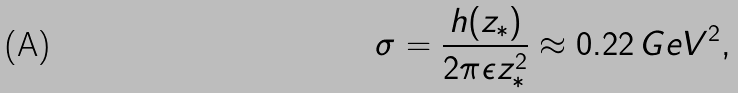Convert formula to latex. <formula><loc_0><loc_0><loc_500><loc_500>\sigma = \frac { h ( z _ { * } ) } { 2 \pi \epsilon z _ { * } ^ { 2 } } \approx 0 . 2 2 \, G e V ^ { 2 } ,</formula> 